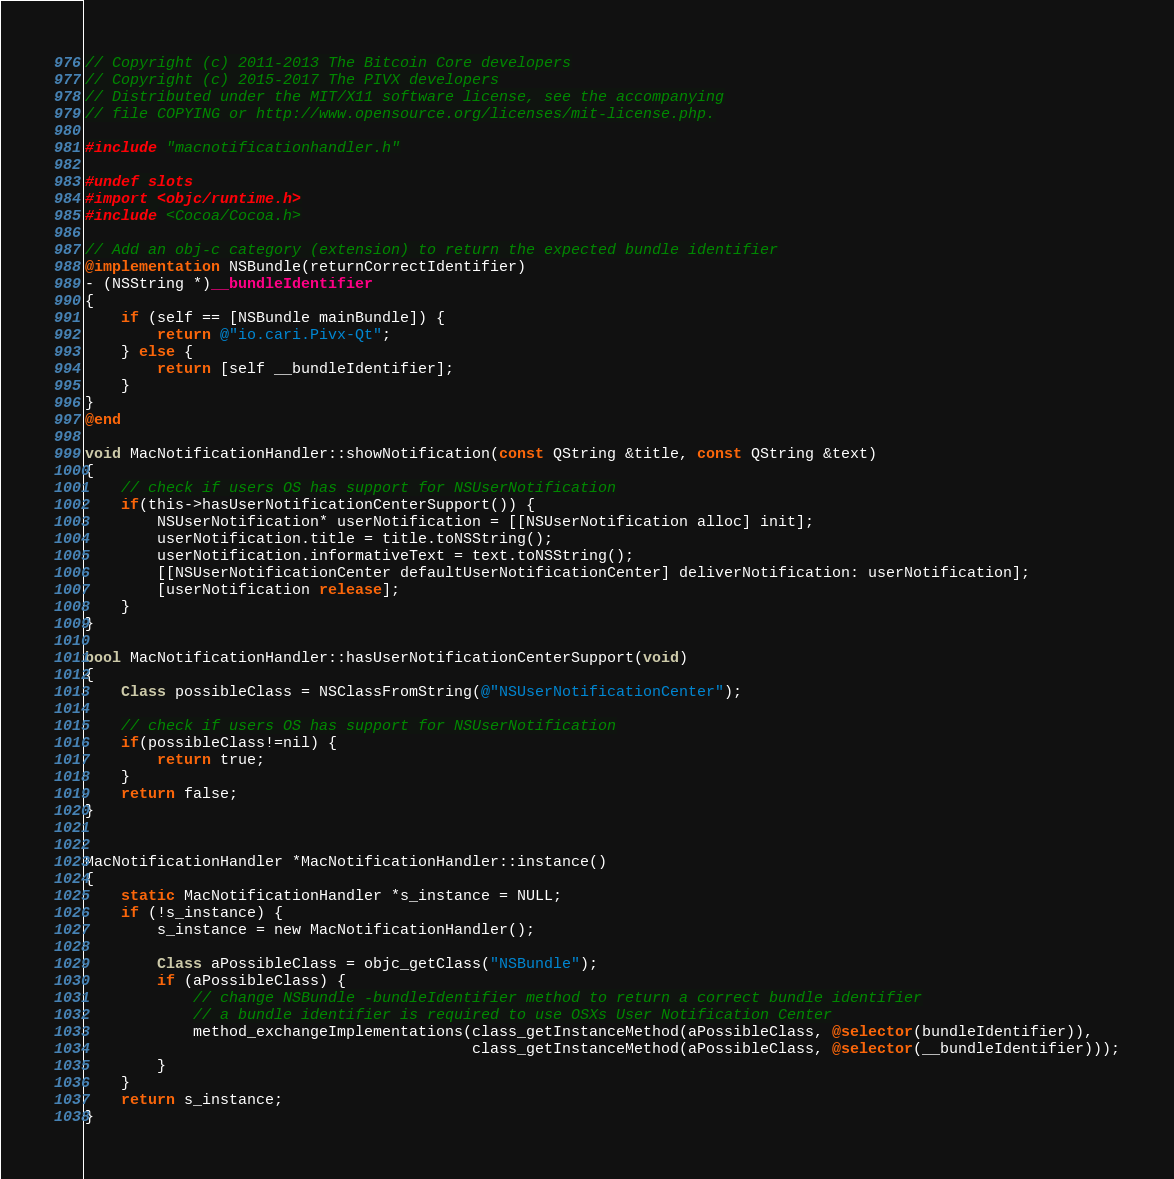Convert code to text. <code><loc_0><loc_0><loc_500><loc_500><_ObjectiveC_>// Copyright (c) 2011-2013 The Bitcoin Core developers
// Copyright (c) 2015-2017 The PIVX developers
// Distributed under the MIT/X11 software license, see the accompanying
// file COPYING or http://www.opensource.org/licenses/mit-license.php.

#include "macnotificationhandler.h"

#undef slots
#import <objc/runtime.h>
#include <Cocoa/Cocoa.h>

// Add an obj-c category (extension) to return the expected bundle identifier
@implementation NSBundle(returnCorrectIdentifier)
- (NSString *)__bundleIdentifier
{
    if (self == [NSBundle mainBundle]) {
        return @"io.cari.Pivx-Qt";
    } else {
        return [self __bundleIdentifier];
    }
}
@end

void MacNotificationHandler::showNotification(const QString &title, const QString &text)
{
    // check if users OS has support for NSUserNotification
    if(this->hasUserNotificationCenterSupport()) {
        NSUserNotification* userNotification = [[NSUserNotification alloc] init];
        userNotification.title = title.toNSString();
        userNotification.informativeText = text.toNSString();
        [[NSUserNotificationCenter defaultUserNotificationCenter] deliverNotification: userNotification];
        [userNotification release];
    }
}

bool MacNotificationHandler::hasUserNotificationCenterSupport(void)
{
    Class possibleClass = NSClassFromString(@"NSUserNotificationCenter");

    // check if users OS has support for NSUserNotification
    if(possibleClass!=nil) {
        return true;
    }
    return false;
}


MacNotificationHandler *MacNotificationHandler::instance()
{
    static MacNotificationHandler *s_instance = NULL;
    if (!s_instance) {
        s_instance = new MacNotificationHandler();
        
        Class aPossibleClass = objc_getClass("NSBundle");
        if (aPossibleClass) {
            // change NSBundle -bundleIdentifier method to return a correct bundle identifier
            // a bundle identifier is required to use OSXs User Notification Center
            method_exchangeImplementations(class_getInstanceMethod(aPossibleClass, @selector(bundleIdentifier)),
                                           class_getInstanceMethod(aPossibleClass, @selector(__bundleIdentifier)));
        }
    }
    return s_instance;
}
</code> 